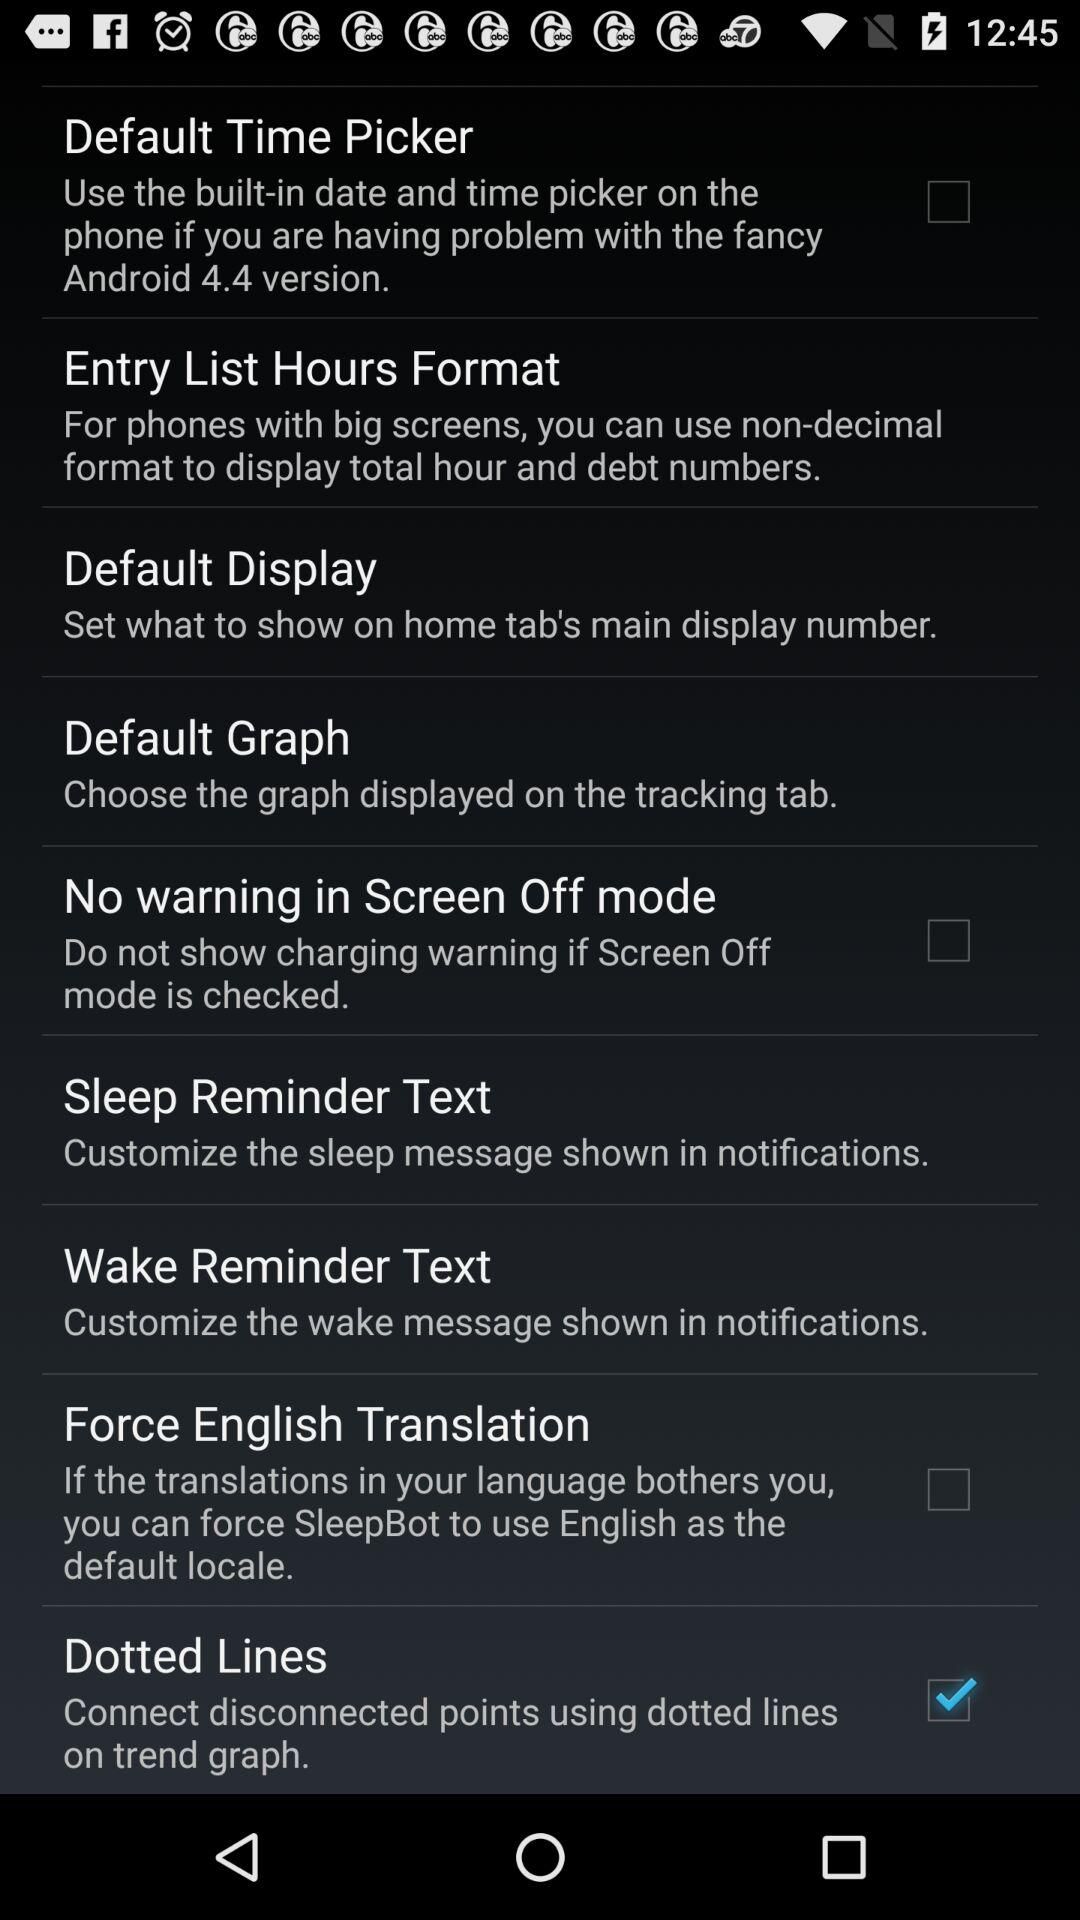Which option was selected? The selected option was "Dotted Lines". 